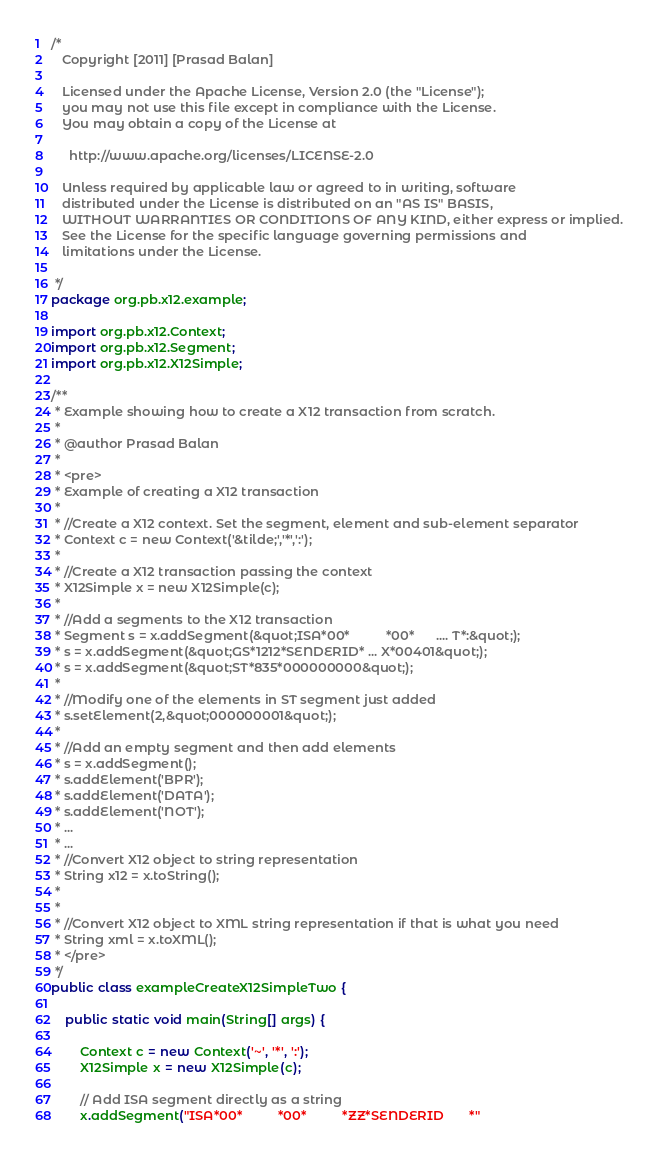<code> <loc_0><loc_0><loc_500><loc_500><_Java_>/*
   Copyright [2011] [Prasad Balan]

   Licensed under the Apache License, Version 2.0 (the "License");
   you may not use this file except in compliance with the License.
   You may obtain a copy of the License at

     http://www.apache.org/licenses/LICENSE-2.0

   Unless required by applicable law or agreed to in writing, software
   distributed under the License is distributed on an "AS IS" BASIS,
   WITHOUT WARRANTIES OR CONDITIONS OF ANY KIND, either express or implied.
   See the License for the specific language governing permissions and
   limitations under the License.

 */
package org.pb.x12.example;

import org.pb.x12.Context;
import org.pb.x12.Segment;
import org.pb.x12.X12Simple;

/**
 * Example showing how to create a X12 transaction from scratch.
 * 
 * @author Prasad Balan
 * 
 * <pre>
 * Example of creating a X12 transaction
 * 
 * //Create a X12 context. Set the segment, element and sub-element separator
 * Context c = new Context('&tilde;','*',':');
 * 
 * //Create a X12 transaction passing the context
 * X12Simple x = new X12Simple(c);
 * 
 * //Add a segments to the X12 transaction
 * Segment s = x.addSegment(&quot;ISA*00*          *00*      .... T*:&quot;);
 * s = x.addSegment(&quot;GS*1212*SENDERID* ... X*00401&quot;);
 * s = x.addSegment(&quot;ST*835*000000000&quot;);
 * 
 * //Modify one of the elements in ST segment just added
 * s.setElement(2,&quot;000000001&quot;);
 * 
 * //Add an empty segment and then add elements
 * s = x.addSegment();
 * s.addElement('BPR');
 * s.addElement('DATA');
 * s.addElement('NOT');
 * ...
 * ...
 * //Convert X12 object to string representation
 * String x12 = x.toString();
 * 
 * 
 * //Convert X12 object to XML string representation if that is what you need
 * String xml = x.toXML();
 * </pre>
 */
public class exampleCreateX12SimpleTwo {

	public static void main(String[] args) {

		Context c = new Context('~', '*', ':');
		X12Simple x = new X12Simple(c);

		// Add ISA segment directly as a string
		x.addSegment("ISA*00*          *00*          *ZZ*SENDERID       *"</code> 